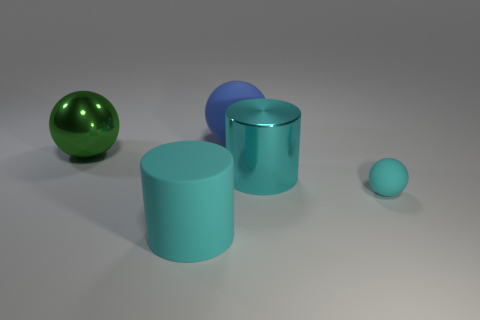What is the color of the other metallic object that is the same shape as the tiny cyan object?
Keep it short and to the point. Green. There is a cyan thing that is in front of the cyan matte thing behind the big cyan rubber cylinder; are there any cyan objects that are to the right of it?
Keep it short and to the point. Yes. The large matte sphere is what color?
Offer a very short reply. Blue. There is a cyan rubber thing on the right side of the big blue thing; is it the same shape as the green shiny object?
Offer a very short reply. Yes. What number of objects are either tiny brown matte cylinders or balls that are to the right of the cyan metallic cylinder?
Keep it short and to the point. 1. Do the big cyan cylinder to the right of the blue sphere and the big green thing have the same material?
Ensure brevity in your answer.  Yes. Is there any other thing that is the same size as the rubber cylinder?
Offer a very short reply. Yes. What material is the cylinder behind the big matte object that is in front of the cyan metallic cylinder?
Ensure brevity in your answer.  Metal. Is the number of big matte cylinders that are behind the small cyan rubber object greater than the number of matte objects to the right of the cyan metallic thing?
Ensure brevity in your answer.  No. How big is the blue matte ball?
Keep it short and to the point. Large. 